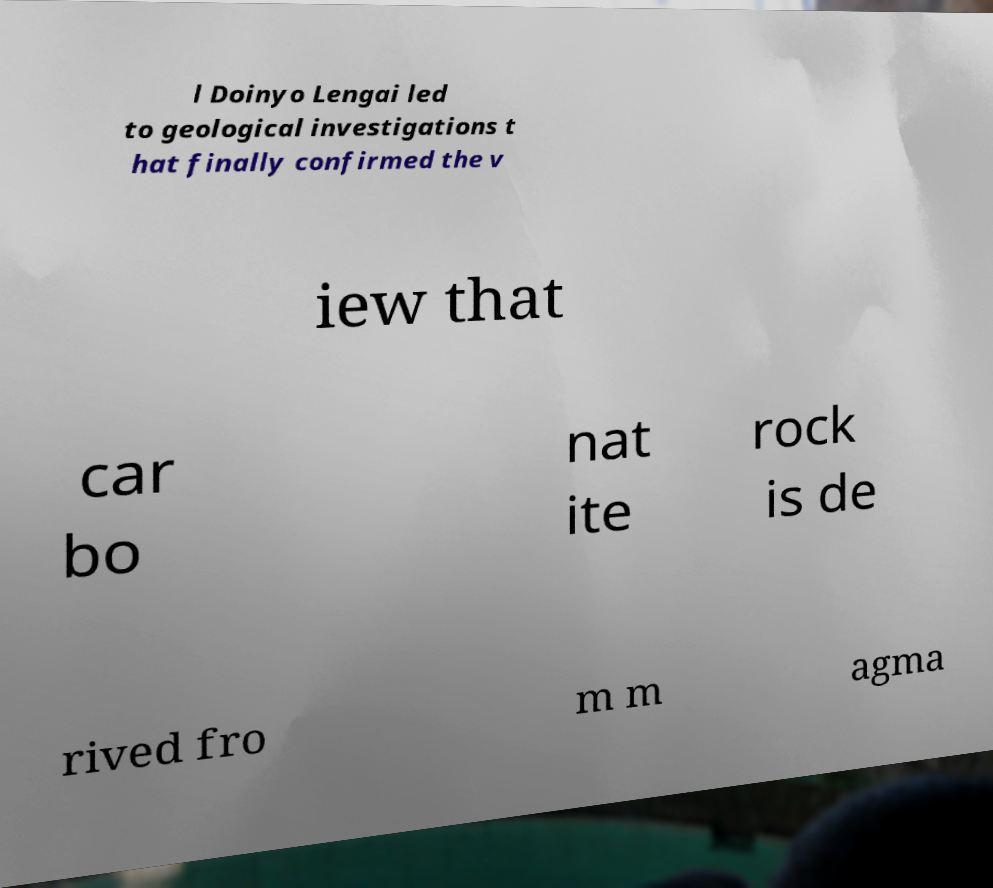Could you extract and type out the text from this image? l Doinyo Lengai led to geological investigations t hat finally confirmed the v iew that car bo nat ite rock is de rived fro m m agma 